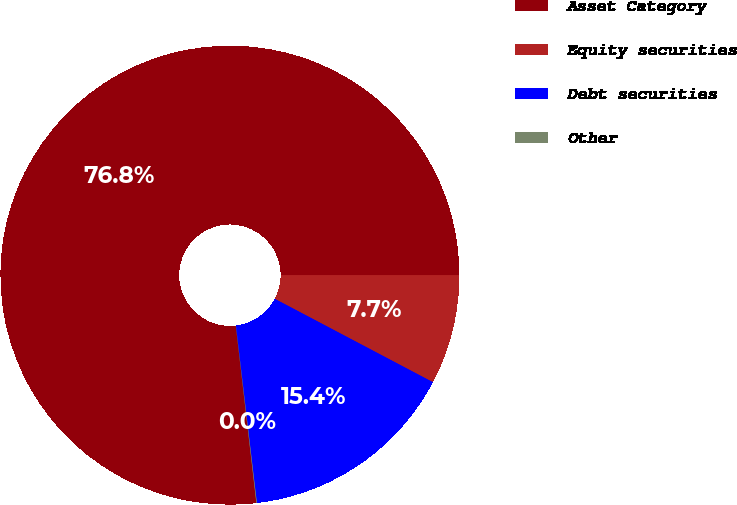Convert chart to OTSL. <chart><loc_0><loc_0><loc_500><loc_500><pie_chart><fcel>Asset Category<fcel>Equity securities<fcel>Debt securities<fcel>Other<nl><fcel>76.84%<fcel>7.72%<fcel>15.4%<fcel>0.04%<nl></chart> 